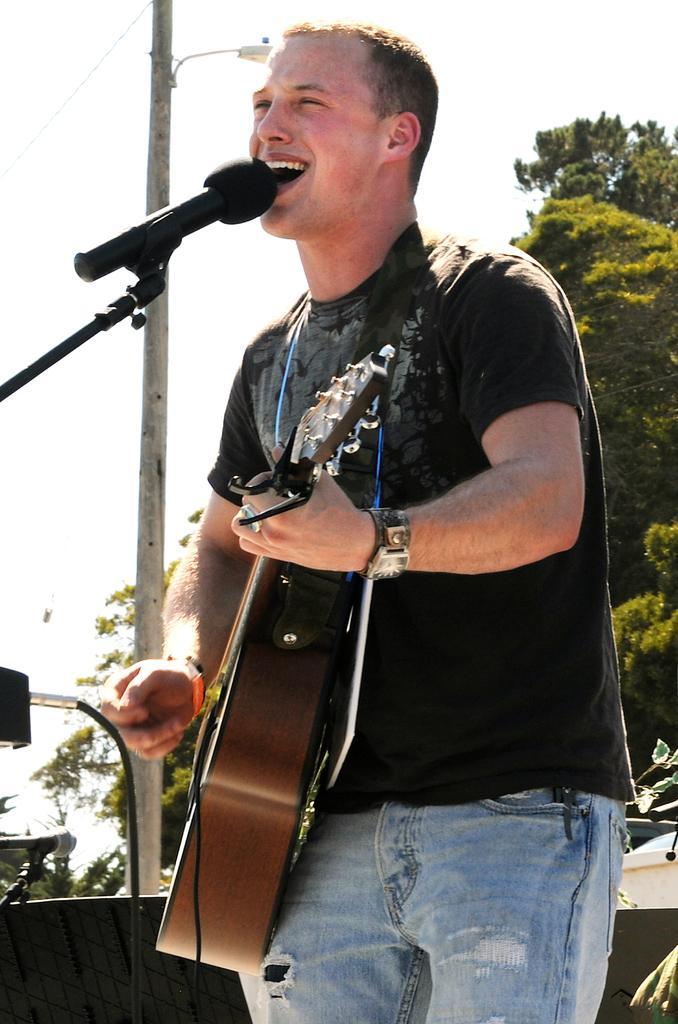Please provide a concise description of this image. In this image there is a man standing in center holding a musical instrument and singing in front of the mic. In the background there are trees electrical pole and sky. 